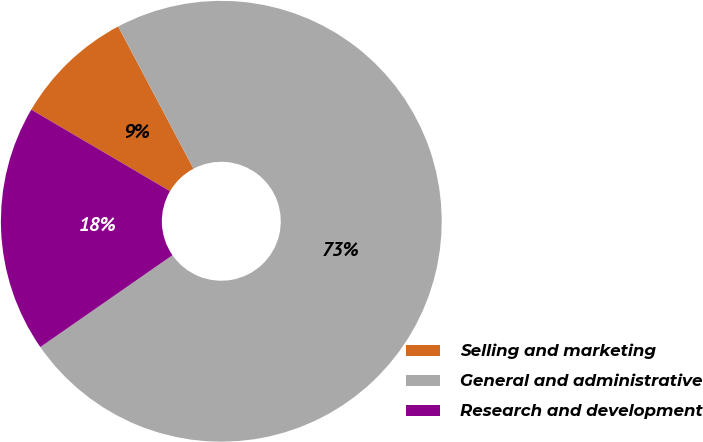<chart> <loc_0><loc_0><loc_500><loc_500><pie_chart><fcel>Selling and marketing<fcel>General and administrative<fcel>Research and development<nl><fcel>8.8%<fcel>73.08%<fcel>18.12%<nl></chart> 